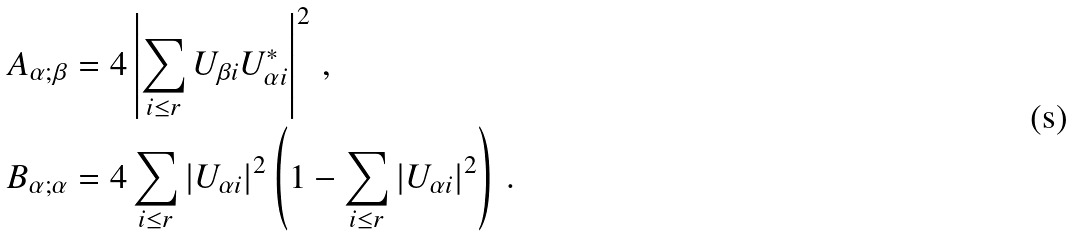Convert formula to latex. <formula><loc_0><loc_0><loc_500><loc_500>& A _ { \alpha ; \beta } = 4 \left | \sum _ { i \leq r } U _ { \beta i } U _ { \alpha i } ^ { * } \right | ^ { 2 } \, , \\ & B _ { \alpha ; \alpha } = 4 \sum _ { i \leq r } | U _ { \alpha i } | ^ { 2 } \left ( 1 - \sum _ { i \leq r } | U _ { \alpha i } | ^ { 2 } \right ) \, .</formula> 